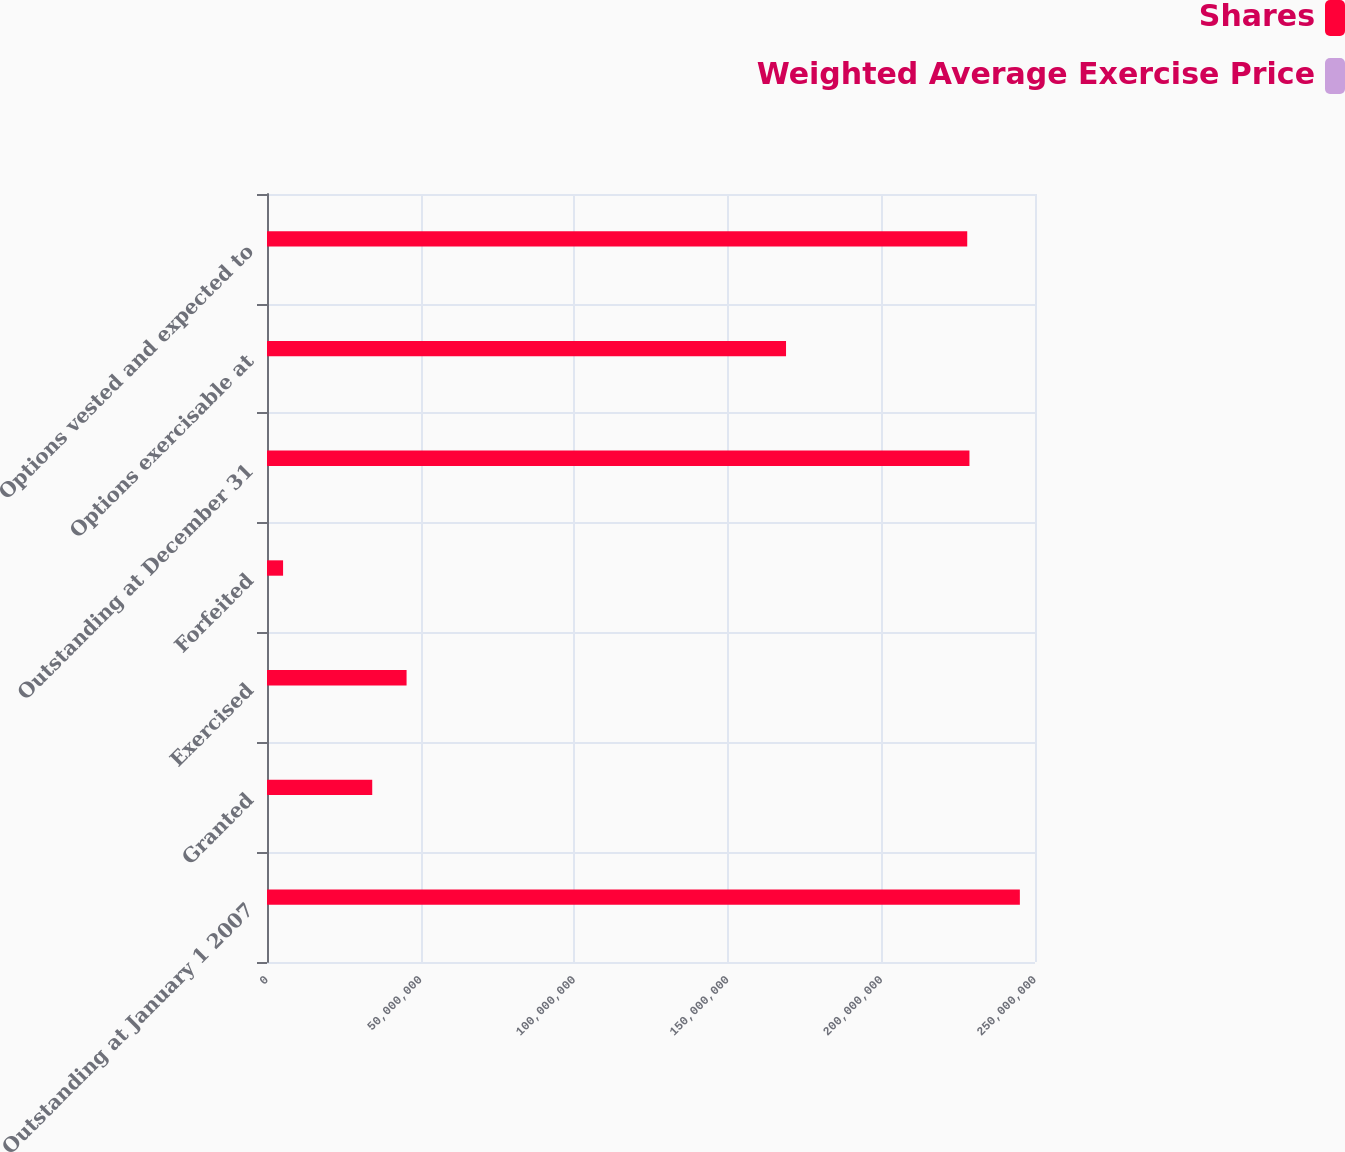Convert chart. <chart><loc_0><loc_0><loc_500><loc_500><stacked_bar_chart><ecel><fcel>Outstanding at January 1 2007<fcel>Granted<fcel>Exercised<fcel>Forfeited<fcel>Outstanding at December 31<fcel>Options exercisable at<fcel>Options vested and expected to<nl><fcel>Shares<fcel>2.45073e+08<fcel>3.42538e+07<fcel>4.54343e+07<fcel>5.23259e+06<fcel>2.2866e+08<fcel>1.68956e+08<fcel>2.27942e+08<nl><fcel>Weighted Average Exercise Price<fcel>36.89<fcel>53.83<fcel>35.56<fcel>46.09<fcel>39.49<fcel>35.86<fcel>39.45<nl></chart> 